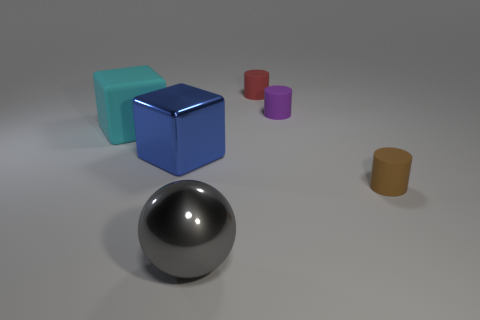Add 2 spheres. How many objects exist? 8 Subtract all cubes. How many objects are left? 4 Subtract 0 red cubes. How many objects are left? 6 Subtract all large blue blocks. Subtract all small purple matte balls. How many objects are left? 5 Add 6 large metallic cubes. How many large metallic cubes are left? 7 Add 2 big matte cubes. How many big matte cubes exist? 3 